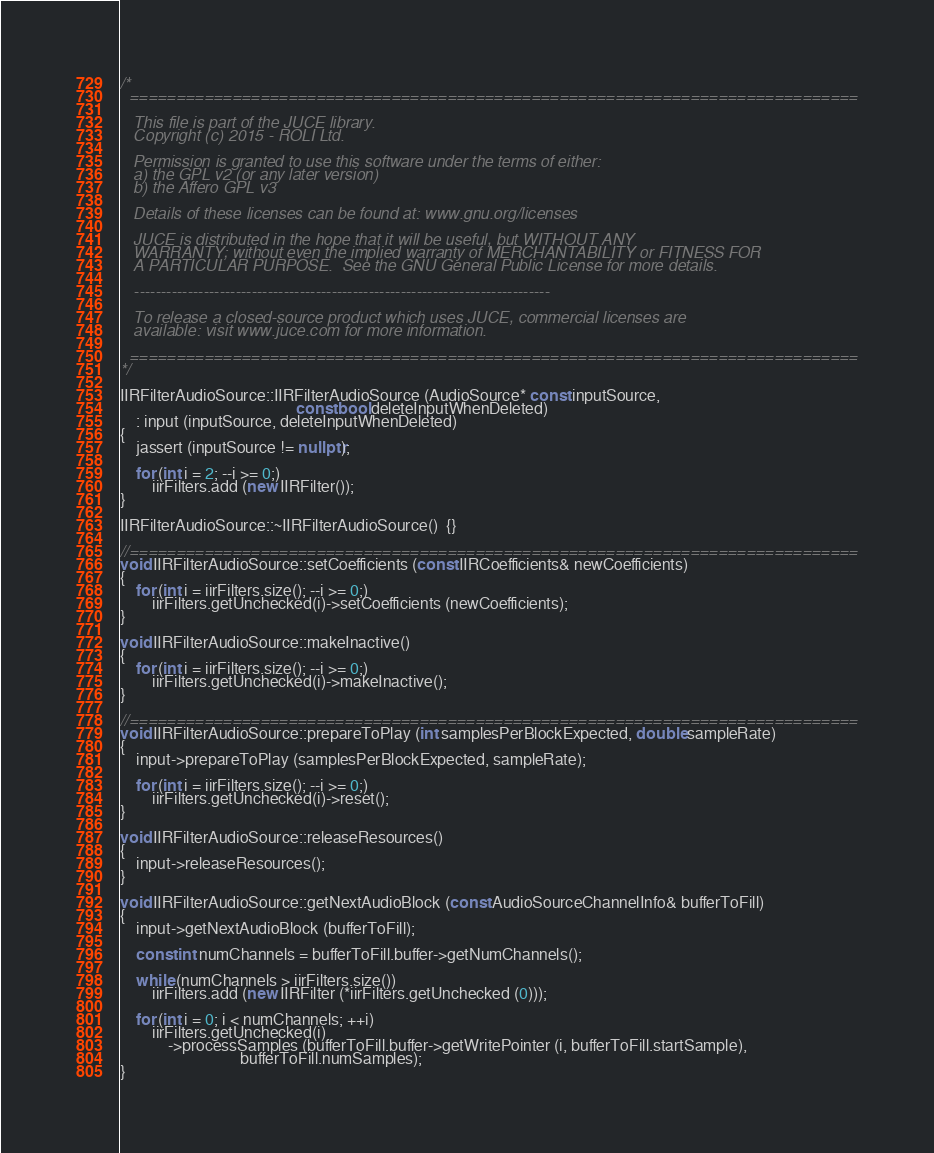<code> <loc_0><loc_0><loc_500><loc_500><_C++_>/*
  ==============================================================================

   This file is part of the JUCE library.
   Copyright (c) 2015 - ROLI Ltd.

   Permission is granted to use this software under the terms of either:
   a) the GPL v2 (or any later version)
   b) the Affero GPL v3

   Details of these licenses can be found at: www.gnu.org/licenses

   JUCE is distributed in the hope that it will be useful, but WITHOUT ANY
   WARRANTY; without even the implied warranty of MERCHANTABILITY or FITNESS FOR
   A PARTICULAR PURPOSE.  See the GNU General Public License for more details.

   ------------------------------------------------------------------------------

   To release a closed-source product which uses JUCE, commercial licenses are
   available: visit www.juce.com for more information.

  ==============================================================================
*/

IIRFilterAudioSource::IIRFilterAudioSource (AudioSource* const inputSource,
                                            const bool deleteInputWhenDeleted)
    : input (inputSource, deleteInputWhenDeleted)
{
    jassert (inputSource != nullptr);

    for (int i = 2; --i >= 0;)
        iirFilters.add (new IIRFilter());
}

IIRFilterAudioSource::~IIRFilterAudioSource()  {}

//==============================================================================
void IIRFilterAudioSource::setCoefficients (const IIRCoefficients& newCoefficients)
{
    for (int i = iirFilters.size(); --i >= 0;)
        iirFilters.getUnchecked(i)->setCoefficients (newCoefficients);
}

void IIRFilterAudioSource::makeInactive()
{
    for (int i = iirFilters.size(); --i >= 0;)
        iirFilters.getUnchecked(i)->makeInactive();
}

//==============================================================================
void IIRFilterAudioSource::prepareToPlay (int samplesPerBlockExpected, double sampleRate)
{
    input->prepareToPlay (samplesPerBlockExpected, sampleRate);

    for (int i = iirFilters.size(); --i >= 0;)
        iirFilters.getUnchecked(i)->reset();
}

void IIRFilterAudioSource::releaseResources()
{
    input->releaseResources();
}

void IIRFilterAudioSource::getNextAudioBlock (const AudioSourceChannelInfo& bufferToFill)
{
    input->getNextAudioBlock (bufferToFill);

    const int numChannels = bufferToFill.buffer->getNumChannels();

    while (numChannels > iirFilters.size())
        iirFilters.add (new IIRFilter (*iirFilters.getUnchecked (0)));

    for (int i = 0; i < numChannels; ++i)
        iirFilters.getUnchecked(i)
            ->processSamples (bufferToFill.buffer->getWritePointer (i, bufferToFill.startSample),
                              bufferToFill.numSamples);
}
</code> 